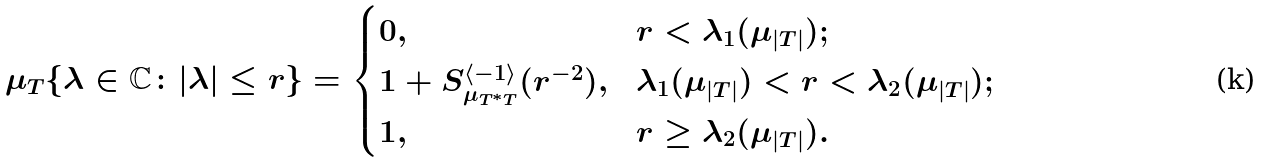Convert formula to latex. <formula><loc_0><loc_0><loc_500><loc_500>\mu _ { T } \{ \lambda \in \mathbb { C } \colon | \lambda | \leq r \} = \begin{cases} 0 , & r < \lambda _ { 1 } ( \mu _ { | T | } ) ; \\ 1 + S ^ { \langle - 1 \rangle } _ { \mu _ { T ^ { * } T } } ( r ^ { - 2 } ) , & \lambda _ { 1 } ( \mu _ { | T | } ) < r < \lambda _ { 2 } ( \mu _ { | T | } ) ; \\ 1 , & r \geq \lambda _ { 2 } ( \mu _ { | T | } ) . \end{cases}</formula> 